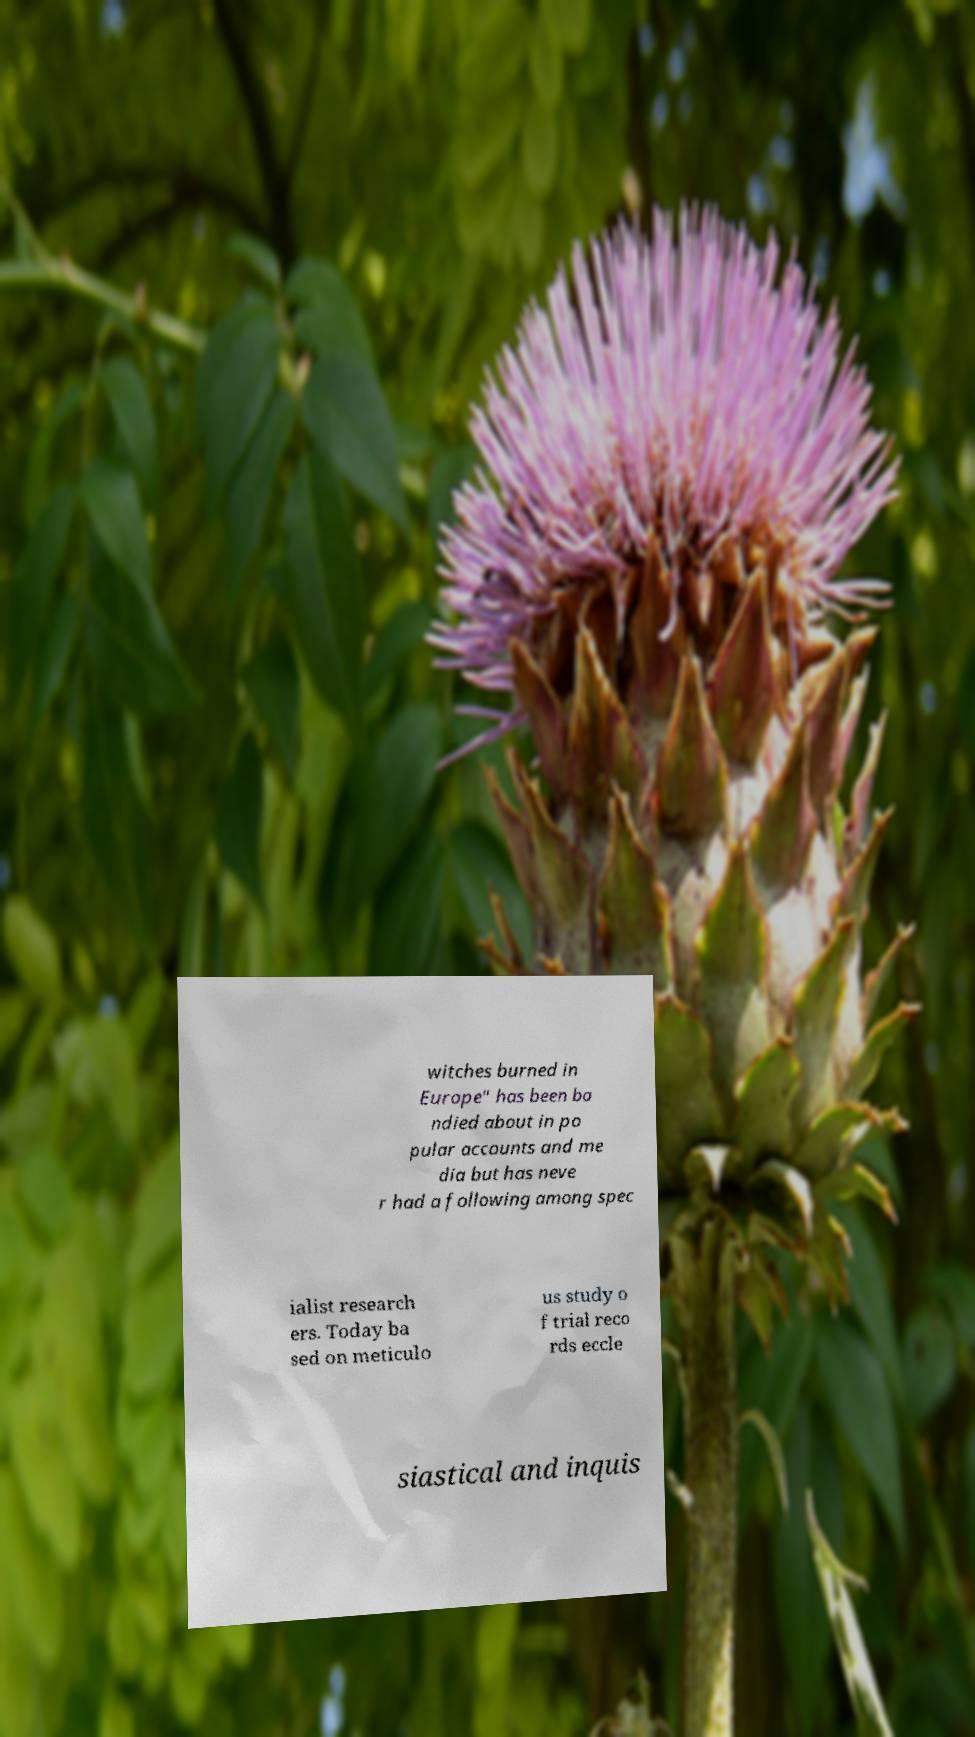What messages or text are displayed in this image? I need them in a readable, typed format. witches burned in Europe" has been ba ndied about in po pular accounts and me dia but has neve r had a following among spec ialist research ers. Today ba sed on meticulo us study o f trial reco rds eccle siastical and inquis 